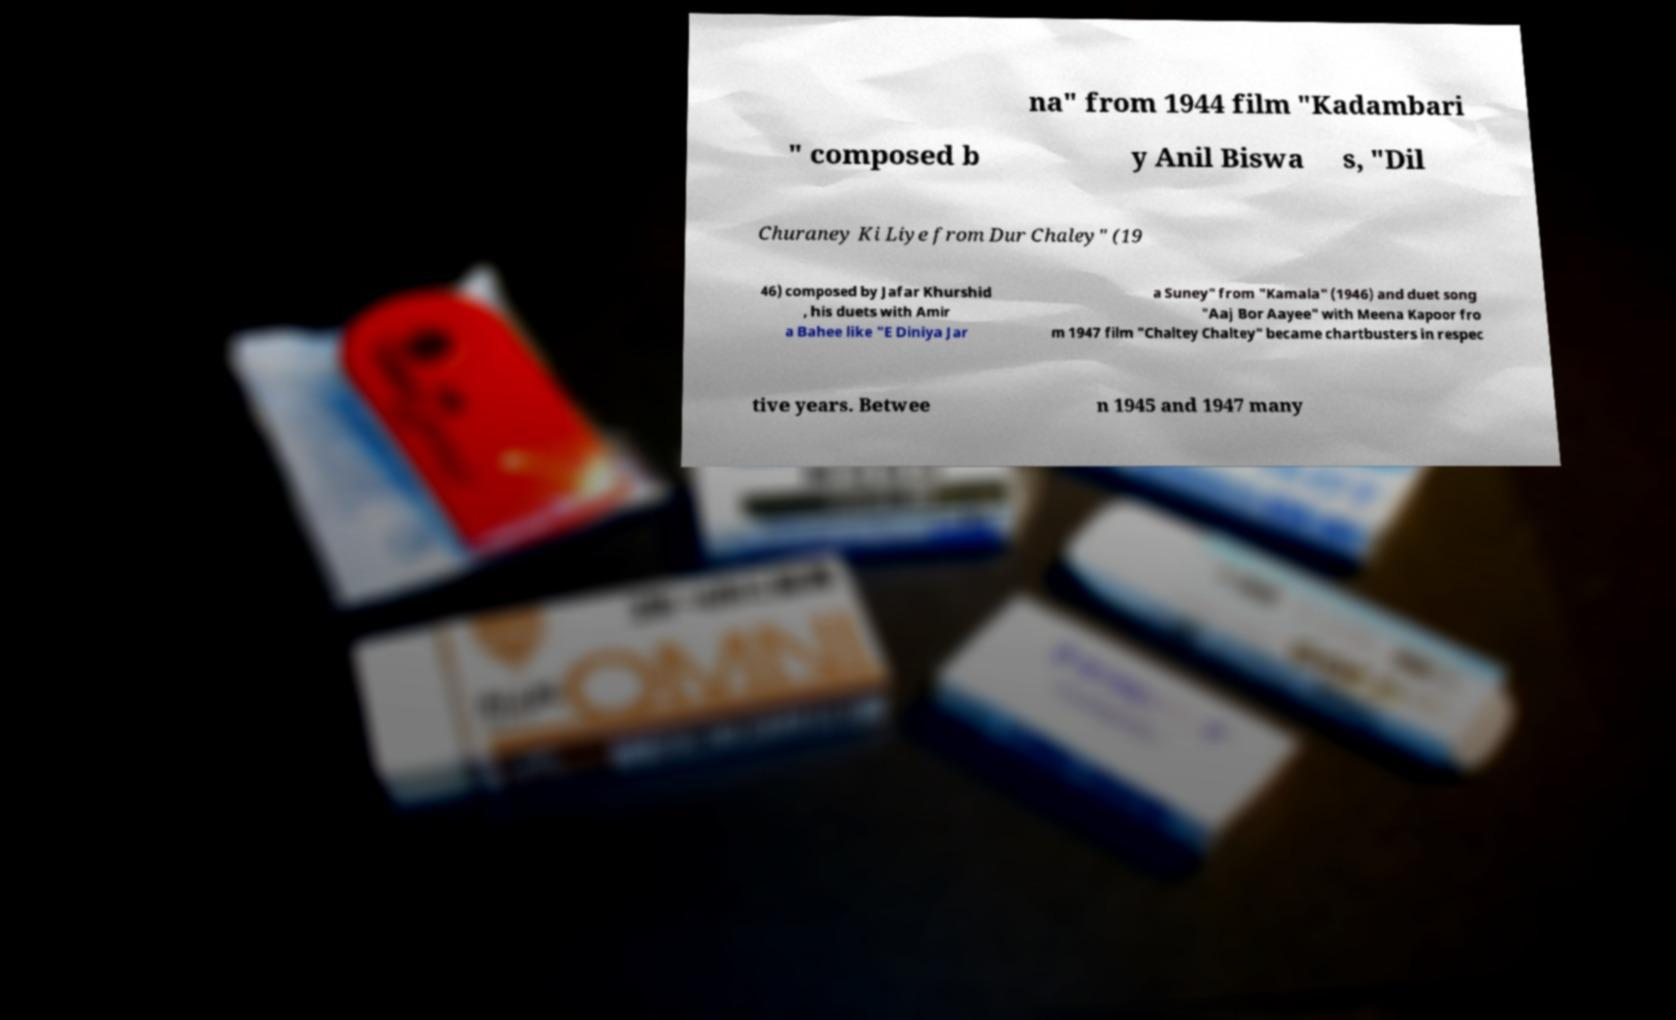Could you extract and type out the text from this image? na" from 1944 film "Kadambari " composed b y Anil Biswa s, "Dil Churaney Ki Liye from Dur Chaley" (19 46) composed by Jafar Khurshid , his duets with Amir a Bahee like "E Diniya Jar a Suney" from "Kamala" (1946) and duet song "Aaj Bor Aayee" with Meena Kapoor fro m 1947 film "Chaltey Chaltey" became chartbusters in respec tive years. Betwee n 1945 and 1947 many 